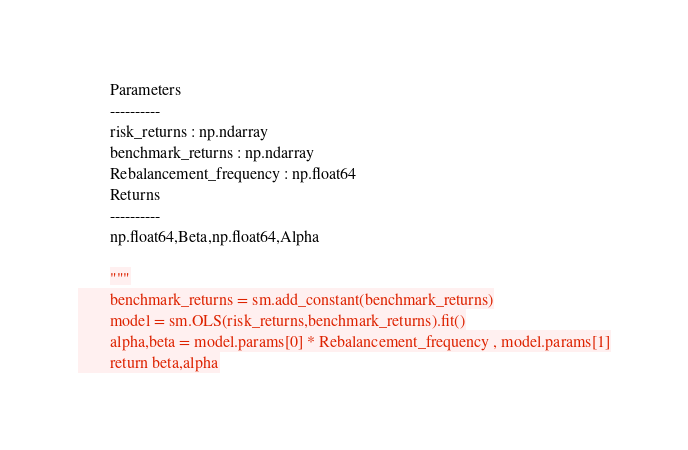Convert code to text. <code><loc_0><loc_0><loc_500><loc_500><_Python_>        Parameters
        ----------
        risk_returns : np.ndarray
        benchmark_returns : np.ndarray
        Rebalancement_frequency : np.float64
        Returns
        ----------
        np.float64,Beta,np.float64,Alpha  

        """
        benchmark_returns = sm.add_constant(benchmark_returns)
        model = sm.OLS(risk_returns,benchmark_returns).fit()
        alpha,beta = model.params[0] * Rebalancement_frequency , model.params[1]
        return beta,alpha</code> 